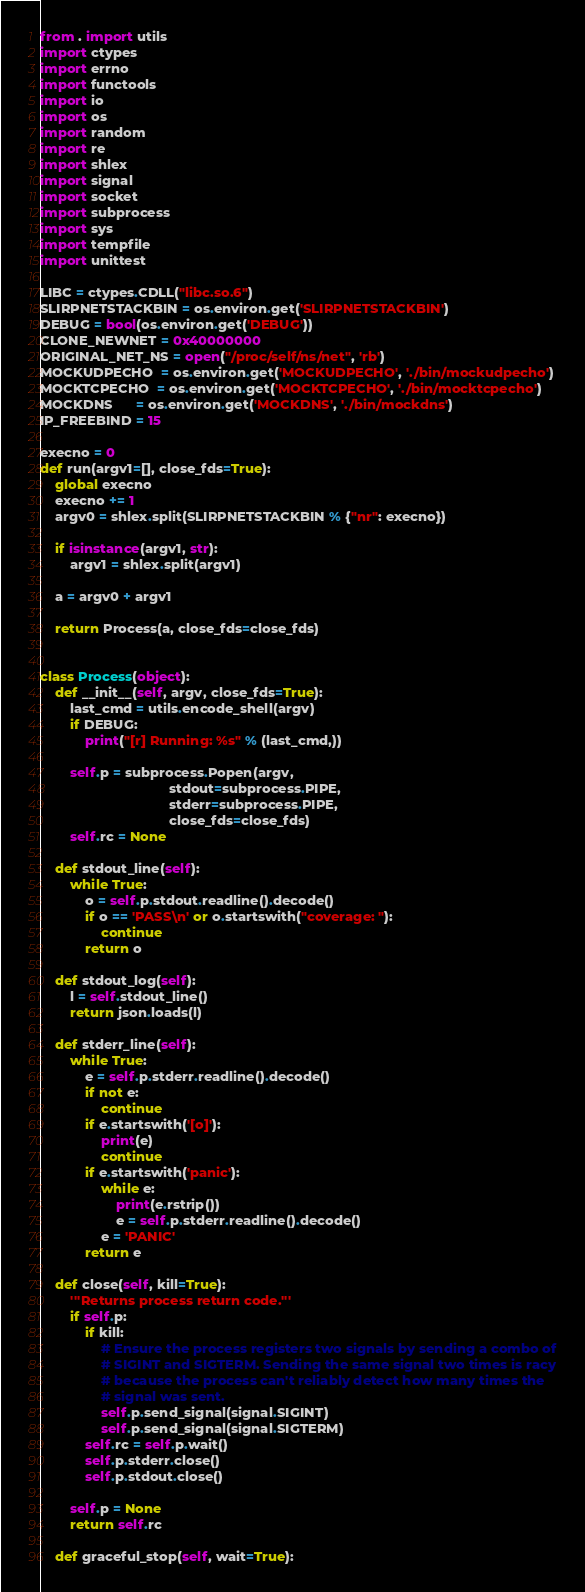Convert code to text. <code><loc_0><loc_0><loc_500><loc_500><_Python_>from . import utils
import ctypes
import errno
import functools
import io
import os
import random
import re
import shlex
import signal
import socket
import subprocess
import sys
import tempfile
import unittest

LIBC = ctypes.CDLL("libc.so.6")
SLIRPNETSTACKBIN = os.environ.get('SLIRPNETSTACKBIN')
DEBUG = bool(os.environ.get('DEBUG'))
CLONE_NEWNET = 0x40000000
ORIGINAL_NET_NS = open("/proc/self/ns/net", 'rb')
MOCKUDPECHO  = os.environ.get('MOCKUDPECHO', './bin/mockudpecho')
MOCKTCPECHO  = os.environ.get('MOCKTCPECHO', './bin/mocktcpecho')
MOCKDNS      = os.environ.get('MOCKDNS', './bin/mockdns')
IP_FREEBIND = 15

execno = 0
def run(argv1=[], close_fds=True):
    global execno
    execno += 1
    argv0 = shlex.split(SLIRPNETSTACKBIN % {"nr": execno})

    if isinstance(argv1, str):
        argv1 = shlex.split(argv1)

    a = argv0 + argv1

    return Process(a, close_fds=close_fds)


class Process(object):
    def __init__(self, argv, close_fds=True):
        last_cmd = utils.encode_shell(argv)
        if DEBUG:
            print("[r] Running: %s" % (last_cmd,))

        self.p = subprocess.Popen(argv,
                                  stdout=subprocess.PIPE,
                                  stderr=subprocess.PIPE,
                                  close_fds=close_fds)
        self.rc = None

    def stdout_line(self):
        while True:
            o = self.p.stdout.readline().decode()
            if o == 'PASS\n' or o.startswith("coverage: "):
                continue
            return o

    def stdout_log(self):
        l = self.stdout_line()
        return json.loads(l)

    def stderr_line(self):
        while True:
            e = self.p.stderr.readline().decode()
            if not e:
                continue
            if e.startswith('[o]'):
                print(e)
                continue
            if e.startswith('panic'):
                while e:
                    print(e.rstrip())
                    e = self.p.stderr.readline().decode()
                e = 'PANIC'
            return e

    def close(self, kill=True):
        '''Returns process return code.'''
        if self.p:
            if kill:
                # Ensure the process registers two signals by sending a combo of
                # SIGINT and SIGTERM. Sending the same signal two times is racy
                # because the process can't reliably detect how many times the
                # signal was sent.
                self.p.send_signal(signal.SIGINT)
                self.p.send_signal(signal.SIGTERM)
            self.rc = self.p.wait()
            self.p.stderr.close()
            self.p.stdout.close()

        self.p = None
        return self.rc

    def graceful_stop(self, wait=True):</code> 